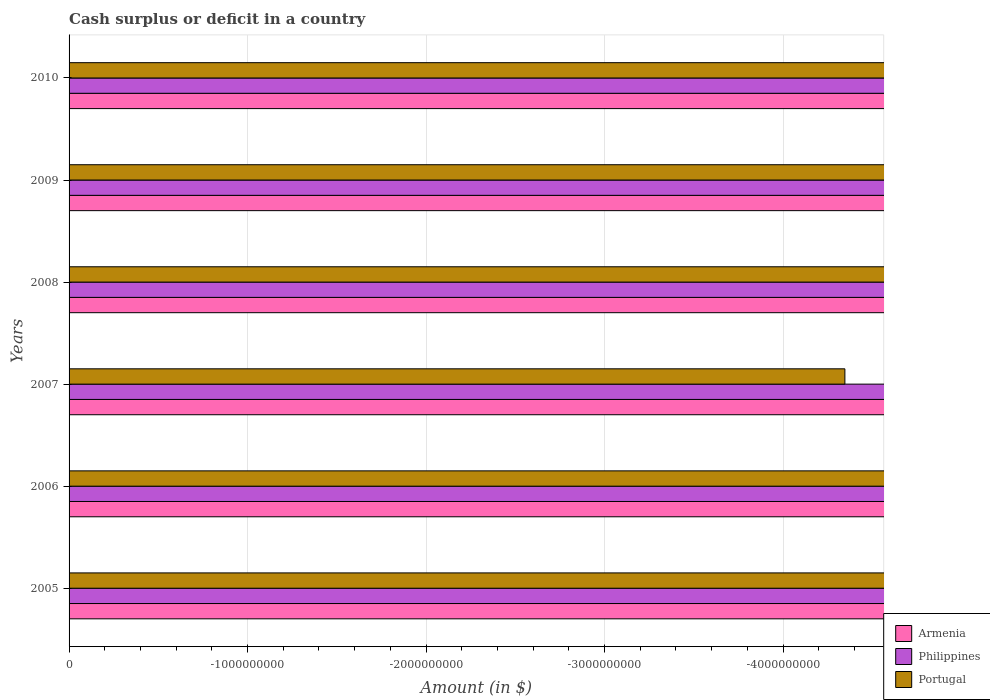How many different coloured bars are there?
Offer a terse response. 0. How many bars are there on the 1st tick from the bottom?
Keep it short and to the point. 0. In how many cases, is the number of bars for a given year not equal to the number of legend labels?
Make the answer very short. 6. Is it the case that in every year, the sum of the amount of cash surplus or deficit in Portugal and amount of cash surplus or deficit in Armenia is greater than the amount of cash surplus or deficit in Philippines?
Make the answer very short. No. Are the values on the major ticks of X-axis written in scientific E-notation?
Provide a short and direct response. No. How are the legend labels stacked?
Keep it short and to the point. Vertical. What is the title of the graph?
Give a very brief answer. Cash surplus or deficit in a country. Does "El Salvador" appear as one of the legend labels in the graph?
Offer a terse response. No. What is the label or title of the X-axis?
Provide a short and direct response. Amount (in $). What is the Amount (in $) of Philippines in 2005?
Keep it short and to the point. 0. What is the Amount (in $) of Portugal in 2005?
Provide a short and direct response. 0. What is the Amount (in $) of Armenia in 2006?
Ensure brevity in your answer.  0. What is the Amount (in $) of Philippines in 2006?
Offer a very short reply. 0. What is the Amount (in $) in Portugal in 2006?
Give a very brief answer. 0. What is the Amount (in $) in Portugal in 2007?
Your response must be concise. 0. What is the Amount (in $) of Armenia in 2008?
Offer a terse response. 0. What is the Amount (in $) of Philippines in 2008?
Offer a terse response. 0. What is the Amount (in $) in Armenia in 2010?
Your answer should be very brief. 0. What is the Amount (in $) in Philippines in 2010?
Your response must be concise. 0. 